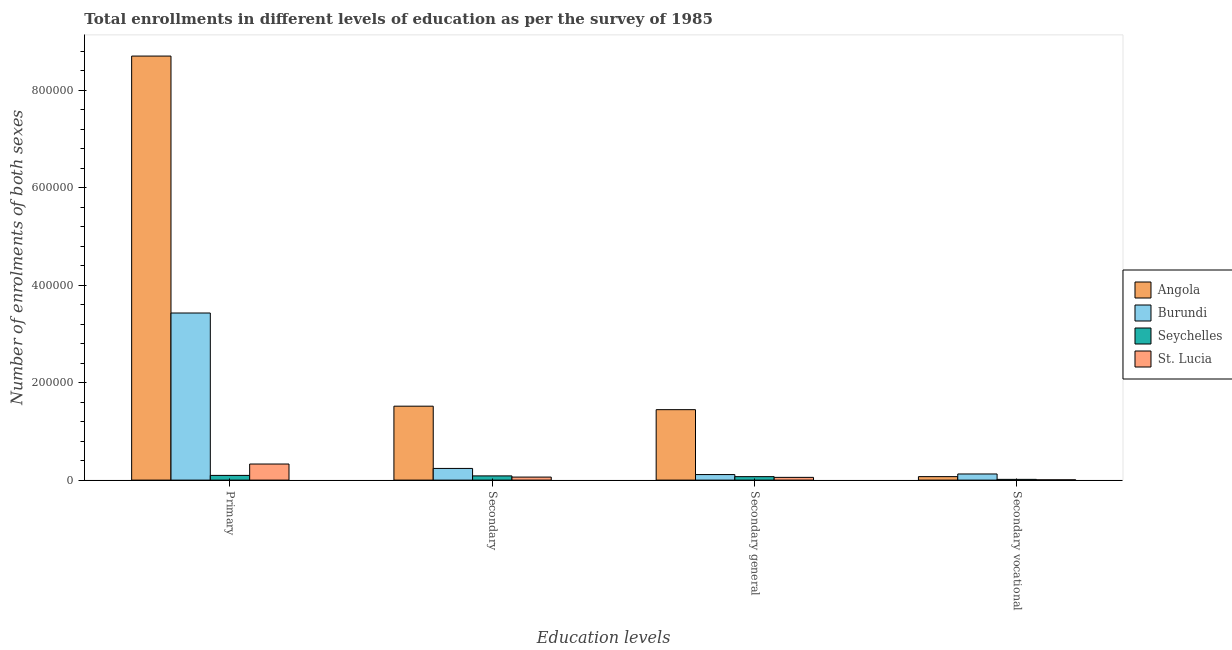Are the number of bars per tick equal to the number of legend labels?
Offer a terse response. Yes. Are the number of bars on each tick of the X-axis equal?
Offer a terse response. Yes. How many bars are there on the 4th tick from the left?
Ensure brevity in your answer.  4. How many bars are there on the 2nd tick from the right?
Ensure brevity in your answer.  4. What is the label of the 2nd group of bars from the left?
Your answer should be very brief. Secondary. What is the number of enrolments in secondary general education in St. Lucia?
Offer a very short reply. 5635. Across all countries, what is the maximum number of enrolments in secondary general education?
Provide a succinct answer. 1.45e+05. Across all countries, what is the minimum number of enrolments in secondary education?
Provide a short and direct response. 6212. In which country was the number of enrolments in secondary vocational education maximum?
Give a very brief answer. Burundi. In which country was the number of enrolments in secondary education minimum?
Offer a very short reply. St. Lucia. What is the total number of enrolments in primary education in the graph?
Offer a very short reply. 1.26e+06. What is the difference between the number of enrolments in primary education in Seychelles and that in St. Lucia?
Provide a short and direct response. -2.34e+04. What is the difference between the number of enrolments in secondary vocational education in Seychelles and the number of enrolments in secondary education in Burundi?
Your response must be concise. -2.24e+04. What is the average number of enrolments in secondary education per country?
Your answer should be compact. 4.77e+04. What is the difference between the number of enrolments in secondary vocational education and number of enrolments in primary education in Burundi?
Your answer should be very brief. -3.30e+05. What is the ratio of the number of enrolments in secondary education in Angola to that in Burundi?
Your response must be concise. 6.33. Is the number of enrolments in secondary vocational education in Burundi less than that in Angola?
Offer a terse response. No. Is the difference between the number of enrolments in secondary education in St. Lucia and Seychelles greater than the difference between the number of enrolments in secondary general education in St. Lucia and Seychelles?
Offer a terse response. No. What is the difference between the highest and the second highest number of enrolments in secondary vocational education?
Keep it short and to the point. 5447. What is the difference between the highest and the lowest number of enrolments in secondary education?
Your response must be concise. 1.46e+05. What does the 4th bar from the left in Secondary general represents?
Provide a succinct answer. St. Lucia. What does the 3rd bar from the right in Secondary general represents?
Your response must be concise. Burundi. Does the graph contain grids?
Give a very brief answer. No. What is the title of the graph?
Offer a terse response. Total enrollments in different levels of education as per the survey of 1985. What is the label or title of the X-axis?
Your answer should be very brief. Education levels. What is the label or title of the Y-axis?
Give a very brief answer. Number of enrolments of both sexes. What is the Number of enrolments of both sexes of Angola in Primary?
Ensure brevity in your answer.  8.70e+05. What is the Number of enrolments of both sexes in Burundi in Primary?
Give a very brief answer. 3.43e+05. What is the Number of enrolments of both sexes of Seychelles in Primary?
Your response must be concise. 9678. What is the Number of enrolments of both sexes in St. Lucia in Primary?
Offer a very short reply. 3.30e+04. What is the Number of enrolments of both sexes in Angola in Secondary?
Offer a terse response. 1.52e+05. What is the Number of enrolments of both sexes in Burundi in Secondary?
Make the answer very short. 2.40e+04. What is the Number of enrolments of both sexes in Seychelles in Secondary?
Your answer should be very brief. 8665. What is the Number of enrolments of both sexes in St. Lucia in Secondary?
Your response must be concise. 6212. What is the Number of enrolments of both sexes in Angola in Secondary general?
Give a very brief answer. 1.45e+05. What is the Number of enrolments of both sexes in Burundi in Secondary general?
Offer a very short reply. 1.14e+04. What is the Number of enrolments of both sexes of Seychelles in Secondary general?
Give a very brief answer. 7125. What is the Number of enrolments of both sexes in St. Lucia in Secondary general?
Ensure brevity in your answer.  5635. What is the Number of enrolments of both sexes in Angola in Secondary vocational?
Make the answer very short. 7147. What is the Number of enrolments of both sexes of Burundi in Secondary vocational?
Ensure brevity in your answer.  1.26e+04. What is the Number of enrolments of both sexes of Seychelles in Secondary vocational?
Offer a very short reply. 1540. What is the Number of enrolments of both sexes of St. Lucia in Secondary vocational?
Offer a very short reply. 577. Across all Education levels, what is the maximum Number of enrolments of both sexes in Angola?
Offer a very short reply. 8.70e+05. Across all Education levels, what is the maximum Number of enrolments of both sexes of Burundi?
Ensure brevity in your answer.  3.43e+05. Across all Education levels, what is the maximum Number of enrolments of both sexes of Seychelles?
Offer a very short reply. 9678. Across all Education levels, what is the maximum Number of enrolments of both sexes in St. Lucia?
Make the answer very short. 3.30e+04. Across all Education levels, what is the minimum Number of enrolments of both sexes of Angola?
Your response must be concise. 7147. Across all Education levels, what is the minimum Number of enrolments of both sexes of Burundi?
Provide a short and direct response. 1.14e+04. Across all Education levels, what is the minimum Number of enrolments of both sexes in Seychelles?
Your answer should be very brief. 1540. Across all Education levels, what is the minimum Number of enrolments of both sexes in St. Lucia?
Make the answer very short. 577. What is the total Number of enrolments of both sexes of Angola in the graph?
Provide a short and direct response. 1.17e+06. What is the total Number of enrolments of both sexes in Burundi in the graph?
Provide a short and direct response. 3.91e+05. What is the total Number of enrolments of both sexes in Seychelles in the graph?
Make the answer very short. 2.70e+04. What is the total Number of enrolments of both sexes in St. Lucia in the graph?
Your answer should be compact. 4.55e+04. What is the difference between the Number of enrolments of both sexes in Angola in Primary and that in Secondary?
Provide a succinct answer. 7.19e+05. What is the difference between the Number of enrolments of both sexes in Burundi in Primary and that in Secondary?
Your answer should be very brief. 3.19e+05. What is the difference between the Number of enrolments of both sexes in Seychelles in Primary and that in Secondary?
Give a very brief answer. 1013. What is the difference between the Number of enrolments of both sexes in St. Lucia in Primary and that in Secondary?
Give a very brief answer. 2.68e+04. What is the difference between the Number of enrolments of both sexes of Angola in Primary and that in Secondary general?
Provide a succinct answer. 7.26e+05. What is the difference between the Number of enrolments of both sexes of Burundi in Primary and that in Secondary general?
Your answer should be compact. 3.32e+05. What is the difference between the Number of enrolments of both sexes of Seychelles in Primary and that in Secondary general?
Your answer should be very brief. 2553. What is the difference between the Number of enrolments of both sexes of St. Lucia in Primary and that in Secondary general?
Keep it short and to the point. 2.74e+04. What is the difference between the Number of enrolments of both sexes of Angola in Primary and that in Secondary vocational?
Provide a short and direct response. 8.63e+05. What is the difference between the Number of enrolments of both sexes in Burundi in Primary and that in Secondary vocational?
Keep it short and to the point. 3.30e+05. What is the difference between the Number of enrolments of both sexes of Seychelles in Primary and that in Secondary vocational?
Your response must be concise. 8138. What is the difference between the Number of enrolments of both sexes of St. Lucia in Primary and that in Secondary vocational?
Your answer should be compact. 3.25e+04. What is the difference between the Number of enrolments of both sexes of Angola in Secondary and that in Secondary general?
Provide a succinct answer. 7147. What is the difference between the Number of enrolments of both sexes in Burundi in Secondary and that in Secondary general?
Offer a terse response. 1.26e+04. What is the difference between the Number of enrolments of both sexes in Seychelles in Secondary and that in Secondary general?
Your answer should be very brief. 1540. What is the difference between the Number of enrolments of both sexes in St. Lucia in Secondary and that in Secondary general?
Your answer should be compact. 577. What is the difference between the Number of enrolments of both sexes of Angola in Secondary and that in Secondary vocational?
Make the answer very short. 1.45e+05. What is the difference between the Number of enrolments of both sexes of Burundi in Secondary and that in Secondary vocational?
Your answer should be very brief. 1.14e+04. What is the difference between the Number of enrolments of both sexes in Seychelles in Secondary and that in Secondary vocational?
Offer a terse response. 7125. What is the difference between the Number of enrolments of both sexes of St. Lucia in Secondary and that in Secondary vocational?
Keep it short and to the point. 5635. What is the difference between the Number of enrolments of both sexes in Angola in Secondary general and that in Secondary vocational?
Keep it short and to the point. 1.37e+05. What is the difference between the Number of enrolments of both sexes in Burundi in Secondary general and that in Secondary vocational?
Your answer should be very brief. -1204. What is the difference between the Number of enrolments of both sexes in Seychelles in Secondary general and that in Secondary vocational?
Keep it short and to the point. 5585. What is the difference between the Number of enrolments of both sexes of St. Lucia in Secondary general and that in Secondary vocational?
Offer a terse response. 5058. What is the difference between the Number of enrolments of both sexes in Angola in Primary and the Number of enrolments of both sexes in Burundi in Secondary?
Your answer should be compact. 8.46e+05. What is the difference between the Number of enrolments of both sexes of Angola in Primary and the Number of enrolments of both sexes of Seychelles in Secondary?
Your response must be concise. 8.62e+05. What is the difference between the Number of enrolments of both sexes of Angola in Primary and the Number of enrolments of both sexes of St. Lucia in Secondary?
Make the answer very short. 8.64e+05. What is the difference between the Number of enrolments of both sexes of Burundi in Primary and the Number of enrolments of both sexes of Seychelles in Secondary?
Your response must be concise. 3.34e+05. What is the difference between the Number of enrolments of both sexes of Burundi in Primary and the Number of enrolments of both sexes of St. Lucia in Secondary?
Your answer should be compact. 3.37e+05. What is the difference between the Number of enrolments of both sexes of Seychelles in Primary and the Number of enrolments of both sexes of St. Lucia in Secondary?
Your response must be concise. 3466. What is the difference between the Number of enrolments of both sexes of Angola in Primary and the Number of enrolments of both sexes of Burundi in Secondary general?
Make the answer very short. 8.59e+05. What is the difference between the Number of enrolments of both sexes in Angola in Primary and the Number of enrolments of both sexes in Seychelles in Secondary general?
Your answer should be very brief. 8.63e+05. What is the difference between the Number of enrolments of both sexes of Angola in Primary and the Number of enrolments of both sexes of St. Lucia in Secondary general?
Provide a succinct answer. 8.65e+05. What is the difference between the Number of enrolments of both sexes in Burundi in Primary and the Number of enrolments of both sexes in Seychelles in Secondary general?
Offer a terse response. 3.36e+05. What is the difference between the Number of enrolments of both sexes in Burundi in Primary and the Number of enrolments of both sexes in St. Lucia in Secondary general?
Make the answer very short. 3.37e+05. What is the difference between the Number of enrolments of both sexes in Seychelles in Primary and the Number of enrolments of both sexes in St. Lucia in Secondary general?
Make the answer very short. 4043. What is the difference between the Number of enrolments of both sexes of Angola in Primary and the Number of enrolments of both sexes of Burundi in Secondary vocational?
Your answer should be very brief. 8.58e+05. What is the difference between the Number of enrolments of both sexes in Angola in Primary and the Number of enrolments of both sexes in Seychelles in Secondary vocational?
Offer a terse response. 8.69e+05. What is the difference between the Number of enrolments of both sexes of Angola in Primary and the Number of enrolments of both sexes of St. Lucia in Secondary vocational?
Provide a succinct answer. 8.70e+05. What is the difference between the Number of enrolments of both sexes in Burundi in Primary and the Number of enrolments of both sexes in Seychelles in Secondary vocational?
Your response must be concise. 3.41e+05. What is the difference between the Number of enrolments of both sexes of Burundi in Primary and the Number of enrolments of both sexes of St. Lucia in Secondary vocational?
Keep it short and to the point. 3.42e+05. What is the difference between the Number of enrolments of both sexes of Seychelles in Primary and the Number of enrolments of both sexes of St. Lucia in Secondary vocational?
Keep it short and to the point. 9101. What is the difference between the Number of enrolments of both sexes of Angola in Secondary and the Number of enrolments of both sexes of Burundi in Secondary general?
Offer a very short reply. 1.40e+05. What is the difference between the Number of enrolments of both sexes in Angola in Secondary and the Number of enrolments of both sexes in Seychelles in Secondary general?
Keep it short and to the point. 1.45e+05. What is the difference between the Number of enrolments of both sexes of Angola in Secondary and the Number of enrolments of both sexes of St. Lucia in Secondary general?
Keep it short and to the point. 1.46e+05. What is the difference between the Number of enrolments of both sexes of Burundi in Secondary and the Number of enrolments of both sexes of Seychelles in Secondary general?
Make the answer very short. 1.69e+04. What is the difference between the Number of enrolments of both sexes in Burundi in Secondary and the Number of enrolments of both sexes in St. Lucia in Secondary general?
Keep it short and to the point. 1.83e+04. What is the difference between the Number of enrolments of both sexes in Seychelles in Secondary and the Number of enrolments of both sexes in St. Lucia in Secondary general?
Keep it short and to the point. 3030. What is the difference between the Number of enrolments of both sexes of Angola in Secondary and the Number of enrolments of both sexes of Burundi in Secondary vocational?
Offer a very short reply. 1.39e+05. What is the difference between the Number of enrolments of both sexes of Angola in Secondary and the Number of enrolments of both sexes of Seychelles in Secondary vocational?
Your answer should be very brief. 1.50e+05. What is the difference between the Number of enrolments of both sexes in Angola in Secondary and the Number of enrolments of both sexes in St. Lucia in Secondary vocational?
Keep it short and to the point. 1.51e+05. What is the difference between the Number of enrolments of both sexes in Burundi in Secondary and the Number of enrolments of both sexes in Seychelles in Secondary vocational?
Your response must be concise. 2.24e+04. What is the difference between the Number of enrolments of both sexes in Burundi in Secondary and the Number of enrolments of both sexes in St. Lucia in Secondary vocational?
Offer a very short reply. 2.34e+04. What is the difference between the Number of enrolments of both sexes of Seychelles in Secondary and the Number of enrolments of both sexes of St. Lucia in Secondary vocational?
Give a very brief answer. 8088. What is the difference between the Number of enrolments of both sexes of Angola in Secondary general and the Number of enrolments of both sexes of Burundi in Secondary vocational?
Your answer should be very brief. 1.32e+05. What is the difference between the Number of enrolments of both sexes in Angola in Secondary general and the Number of enrolments of both sexes in Seychelles in Secondary vocational?
Provide a short and direct response. 1.43e+05. What is the difference between the Number of enrolments of both sexes in Angola in Secondary general and the Number of enrolments of both sexes in St. Lucia in Secondary vocational?
Your answer should be very brief. 1.44e+05. What is the difference between the Number of enrolments of both sexes in Burundi in Secondary general and the Number of enrolments of both sexes in Seychelles in Secondary vocational?
Your response must be concise. 9850. What is the difference between the Number of enrolments of both sexes of Burundi in Secondary general and the Number of enrolments of both sexes of St. Lucia in Secondary vocational?
Keep it short and to the point. 1.08e+04. What is the difference between the Number of enrolments of both sexes of Seychelles in Secondary general and the Number of enrolments of both sexes of St. Lucia in Secondary vocational?
Your answer should be compact. 6548. What is the average Number of enrolments of both sexes in Angola per Education levels?
Give a very brief answer. 2.93e+05. What is the average Number of enrolments of both sexes of Burundi per Education levels?
Offer a very short reply. 9.77e+04. What is the average Number of enrolments of both sexes of Seychelles per Education levels?
Your response must be concise. 6752. What is the average Number of enrolments of both sexes in St. Lucia per Education levels?
Offer a very short reply. 1.14e+04. What is the difference between the Number of enrolments of both sexes of Angola and Number of enrolments of both sexes of Burundi in Primary?
Give a very brief answer. 5.27e+05. What is the difference between the Number of enrolments of both sexes in Angola and Number of enrolments of both sexes in Seychelles in Primary?
Ensure brevity in your answer.  8.61e+05. What is the difference between the Number of enrolments of both sexes in Angola and Number of enrolments of both sexes in St. Lucia in Primary?
Keep it short and to the point. 8.37e+05. What is the difference between the Number of enrolments of both sexes of Burundi and Number of enrolments of both sexes of Seychelles in Primary?
Keep it short and to the point. 3.33e+05. What is the difference between the Number of enrolments of both sexes of Burundi and Number of enrolments of both sexes of St. Lucia in Primary?
Offer a terse response. 3.10e+05. What is the difference between the Number of enrolments of both sexes in Seychelles and Number of enrolments of both sexes in St. Lucia in Primary?
Your response must be concise. -2.34e+04. What is the difference between the Number of enrolments of both sexes in Angola and Number of enrolments of both sexes in Burundi in Secondary?
Your answer should be compact. 1.28e+05. What is the difference between the Number of enrolments of both sexes in Angola and Number of enrolments of both sexes in Seychelles in Secondary?
Provide a short and direct response. 1.43e+05. What is the difference between the Number of enrolments of both sexes in Angola and Number of enrolments of both sexes in St. Lucia in Secondary?
Make the answer very short. 1.46e+05. What is the difference between the Number of enrolments of both sexes of Burundi and Number of enrolments of both sexes of Seychelles in Secondary?
Keep it short and to the point. 1.53e+04. What is the difference between the Number of enrolments of both sexes in Burundi and Number of enrolments of both sexes in St. Lucia in Secondary?
Offer a very short reply. 1.78e+04. What is the difference between the Number of enrolments of both sexes in Seychelles and Number of enrolments of both sexes in St. Lucia in Secondary?
Provide a succinct answer. 2453. What is the difference between the Number of enrolments of both sexes in Angola and Number of enrolments of both sexes in Burundi in Secondary general?
Your response must be concise. 1.33e+05. What is the difference between the Number of enrolments of both sexes in Angola and Number of enrolments of both sexes in Seychelles in Secondary general?
Make the answer very short. 1.37e+05. What is the difference between the Number of enrolments of both sexes in Angola and Number of enrolments of both sexes in St. Lucia in Secondary general?
Your answer should be compact. 1.39e+05. What is the difference between the Number of enrolments of both sexes of Burundi and Number of enrolments of both sexes of Seychelles in Secondary general?
Ensure brevity in your answer.  4265. What is the difference between the Number of enrolments of both sexes in Burundi and Number of enrolments of both sexes in St. Lucia in Secondary general?
Provide a short and direct response. 5755. What is the difference between the Number of enrolments of both sexes of Seychelles and Number of enrolments of both sexes of St. Lucia in Secondary general?
Your answer should be very brief. 1490. What is the difference between the Number of enrolments of both sexes of Angola and Number of enrolments of both sexes of Burundi in Secondary vocational?
Offer a very short reply. -5447. What is the difference between the Number of enrolments of both sexes in Angola and Number of enrolments of both sexes in Seychelles in Secondary vocational?
Your answer should be compact. 5607. What is the difference between the Number of enrolments of both sexes of Angola and Number of enrolments of both sexes of St. Lucia in Secondary vocational?
Keep it short and to the point. 6570. What is the difference between the Number of enrolments of both sexes in Burundi and Number of enrolments of both sexes in Seychelles in Secondary vocational?
Offer a very short reply. 1.11e+04. What is the difference between the Number of enrolments of both sexes in Burundi and Number of enrolments of both sexes in St. Lucia in Secondary vocational?
Your response must be concise. 1.20e+04. What is the difference between the Number of enrolments of both sexes of Seychelles and Number of enrolments of both sexes of St. Lucia in Secondary vocational?
Your answer should be very brief. 963. What is the ratio of the Number of enrolments of both sexes of Angola in Primary to that in Secondary?
Your answer should be compact. 5.74. What is the ratio of the Number of enrolments of both sexes of Burundi in Primary to that in Secondary?
Give a very brief answer. 14.3. What is the ratio of the Number of enrolments of both sexes in Seychelles in Primary to that in Secondary?
Keep it short and to the point. 1.12. What is the ratio of the Number of enrolments of both sexes in St. Lucia in Primary to that in Secondary?
Make the answer very short. 5.32. What is the ratio of the Number of enrolments of both sexes of Angola in Primary to that in Secondary general?
Make the answer very short. 6.02. What is the ratio of the Number of enrolments of both sexes of Burundi in Primary to that in Secondary general?
Give a very brief answer. 30.12. What is the ratio of the Number of enrolments of both sexes in Seychelles in Primary to that in Secondary general?
Your answer should be very brief. 1.36. What is the ratio of the Number of enrolments of both sexes in St. Lucia in Primary to that in Secondary general?
Offer a terse response. 5.86. What is the ratio of the Number of enrolments of both sexes of Angola in Primary to that in Secondary vocational?
Your answer should be compact. 121.79. What is the ratio of the Number of enrolments of both sexes of Burundi in Primary to that in Secondary vocational?
Ensure brevity in your answer.  27.24. What is the ratio of the Number of enrolments of both sexes in Seychelles in Primary to that in Secondary vocational?
Your answer should be compact. 6.28. What is the ratio of the Number of enrolments of both sexes in St. Lucia in Primary to that in Secondary vocational?
Give a very brief answer. 57.25. What is the ratio of the Number of enrolments of both sexes in Angola in Secondary to that in Secondary general?
Give a very brief answer. 1.05. What is the ratio of the Number of enrolments of both sexes of Burundi in Secondary to that in Secondary general?
Keep it short and to the point. 2.11. What is the ratio of the Number of enrolments of both sexes of Seychelles in Secondary to that in Secondary general?
Your response must be concise. 1.22. What is the ratio of the Number of enrolments of both sexes in St. Lucia in Secondary to that in Secondary general?
Provide a short and direct response. 1.1. What is the ratio of the Number of enrolments of both sexes in Angola in Secondary to that in Secondary vocational?
Your answer should be very brief. 21.23. What is the ratio of the Number of enrolments of both sexes in Burundi in Secondary to that in Secondary vocational?
Your answer should be very brief. 1.9. What is the ratio of the Number of enrolments of both sexes of Seychelles in Secondary to that in Secondary vocational?
Give a very brief answer. 5.63. What is the ratio of the Number of enrolments of both sexes in St. Lucia in Secondary to that in Secondary vocational?
Your answer should be very brief. 10.77. What is the ratio of the Number of enrolments of both sexes in Angola in Secondary general to that in Secondary vocational?
Ensure brevity in your answer.  20.23. What is the ratio of the Number of enrolments of both sexes of Burundi in Secondary general to that in Secondary vocational?
Make the answer very short. 0.9. What is the ratio of the Number of enrolments of both sexes in Seychelles in Secondary general to that in Secondary vocational?
Offer a terse response. 4.63. What is the ratio of the Number of enrolments of both sexes in St. Lucia in Secondary general to that in Secondary vocational?
Ensure brevity in your answer.  9.77. What is the difference between the highest and the second highest Number of enrolments of both sexes of Angola?
Your answer should be very brief. 7.19e+05. What is the difference between the highest and the second highest Number of enrolments of both sexes in Burundi?
Keep it short and to the point. 3.19e+05. What is the difference between the highest and the second highest Number of enrolments of both sexes in Seychelles?
Make the answer very short. 1013. What is the difference between the highest and the second highest Number of enrolments of both sexes of St. Lucia?
Ensure brevity in your answer.  2.68e+04. What is the difference between the highest and the lowest Number of enrolments of both sexes of Angola?
Provide a succinct answer. 8.63e+05. What is the difference between the highest and the lowest Number of enrolments of both sexes in Burundi?
Keep it short and to the point. 3.32e+05. What is the difference between the highest and the lowest Number of enrolments of both sexes of Seychelles?
Provide a short and direct response. 8138. What is the difference between the highest and the lowest Number of enrolments of both sexes of St. Lucia?
Your response must be concise. 3.25e+04. 